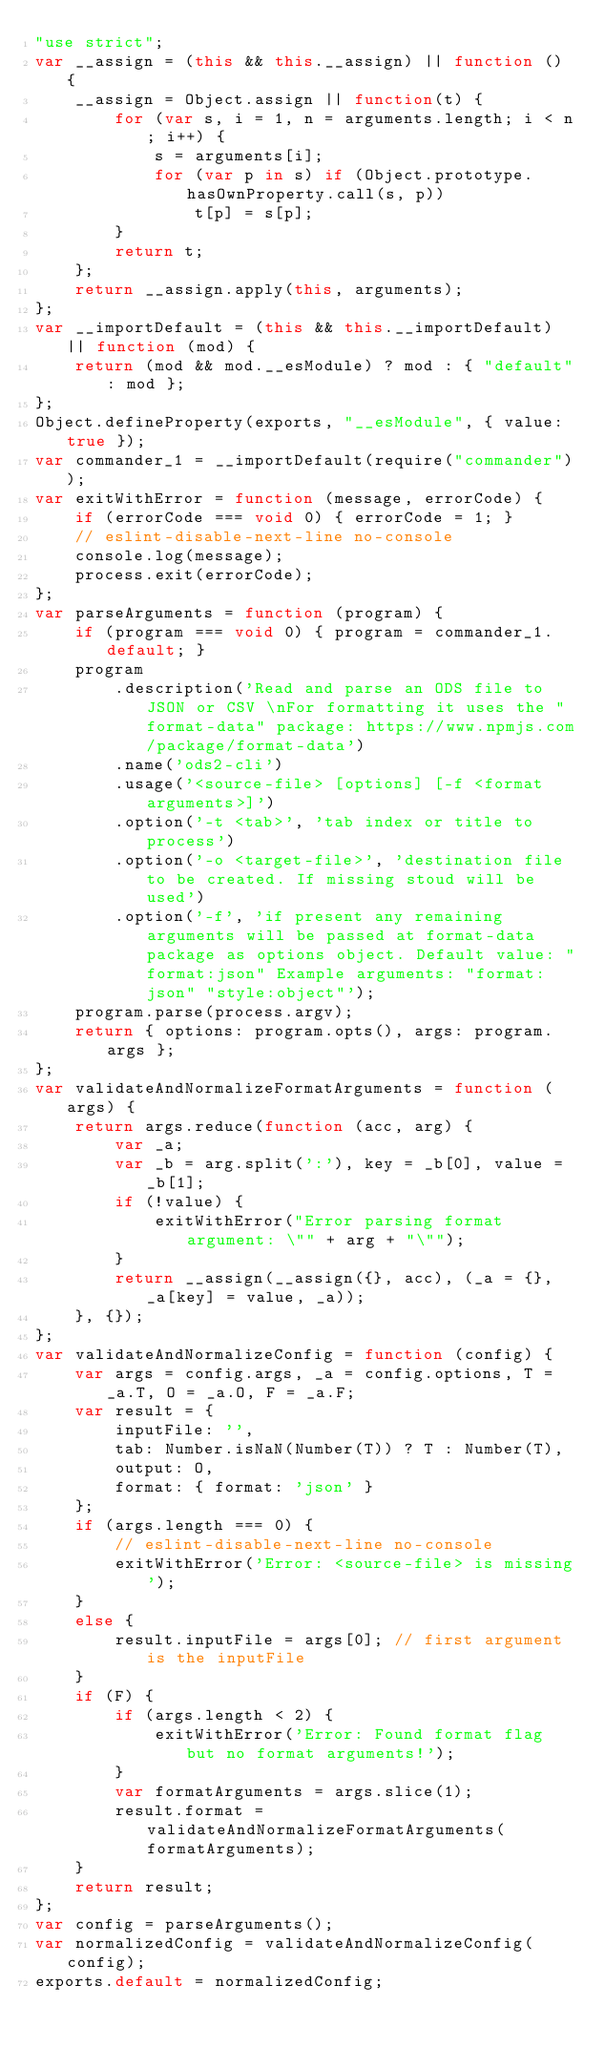<code> <loc_0><loc_0><loc_500><loc_500><_JavaScript_>"use strict";
var __assign = (this && this.__assign) || function () {
    __assign = Object.assign || function(t) {
        for (var s, i = 1, n = arguments.length; i < n; i++) {
            s = arguments[i];
            for (var p in s) if (Object.prototype.hasOwnProperty.call(s, p))
                t[p] = s[p];
        }
        return t;
    };
    return __assign.apply(this, arguments);
};
var __importDefault = (this && this.__importDefault) || function (mod) {
    return (mod && mod.__esModule) ? mod : { "default": mod };
};
Object.defineProperty(exports, "__esModule", { value: true });
var commander_1 = __importDefault(require("commander"));
var exitWithError = function (message, errorCode) {
    if (errorCode === void 0) { errorCode = 1; }
    // eslint-disable-next-line no-console
    console.log(message);
    process.exit(errorCode);
};
var parseArguments = function (program) {
    if (program === void 0) { program = commander_1.default; }
    program
        .description('Read and parse an ODS file to JSON or CSV \nFor formatting it uses the "format-data" package: https://www.npmjs.com/package/format-data')
        .name('ods2-cli')
        .usage('<source-file> [options] [-f <format arguments>]')
        .option('-t <tab>', 'tab index or title to process')
        .option('-o <target-file>', 'destination file to be created. If missing stoud will be used')
        .option('-f', 'if present any remaining arguments will be passed at format-data package as options object. Default value: "format:json" Example arguments: "format:json" "style:object"');
    program.parse(process.argv);
    return { options: program.opts(), args: program.args };
};
var validateAndNormalizeFormatArguments = function (args) {
    return args.reduce(function (acc, arg) {
        var _a;
        var _b = arg.split(':'), key = _b[0], value = _b[1];
        if (!value) {
            exitWithError("Error parsing format argument: \"" + arg + "\"");
        }
        return __assign(__assign({}, acc), (_a = {}, _a[key] = value, _a));
    }, {});
};
var validateAndNormalizeConfig = function (config) {
    var args = config.args, _a = config.options, T = _a.T, O = _a.O, F = _a.F;
    var result = {
        inputFile: '',
        tab: Number.isNaN(Number(T)) ? T : Number(T),
        output: O,
        format: { format: 'json' }
    };
    if (args.length === 0) {
        // eslint-disable-next-line no-console
        exitWithError('Error: <source-file> is missing');
    }
    else {
        result.inputFile = args[0]; // first argument is the inputFile
    }
    if (F) {
        if (args.length < 2) {
            exitWithError('Error: Found format flag but no format arguments!');
        }
        var formatArguments = args.slice(1);
        result.format = validateAndNormalizeFormatArguments(formatArguments);
    }
    return result;
};
var config = parseArguments();
var normalizedConfig = validateAndNormalizeConfig(config);
exports.default = normalizedConfig;
</code> 